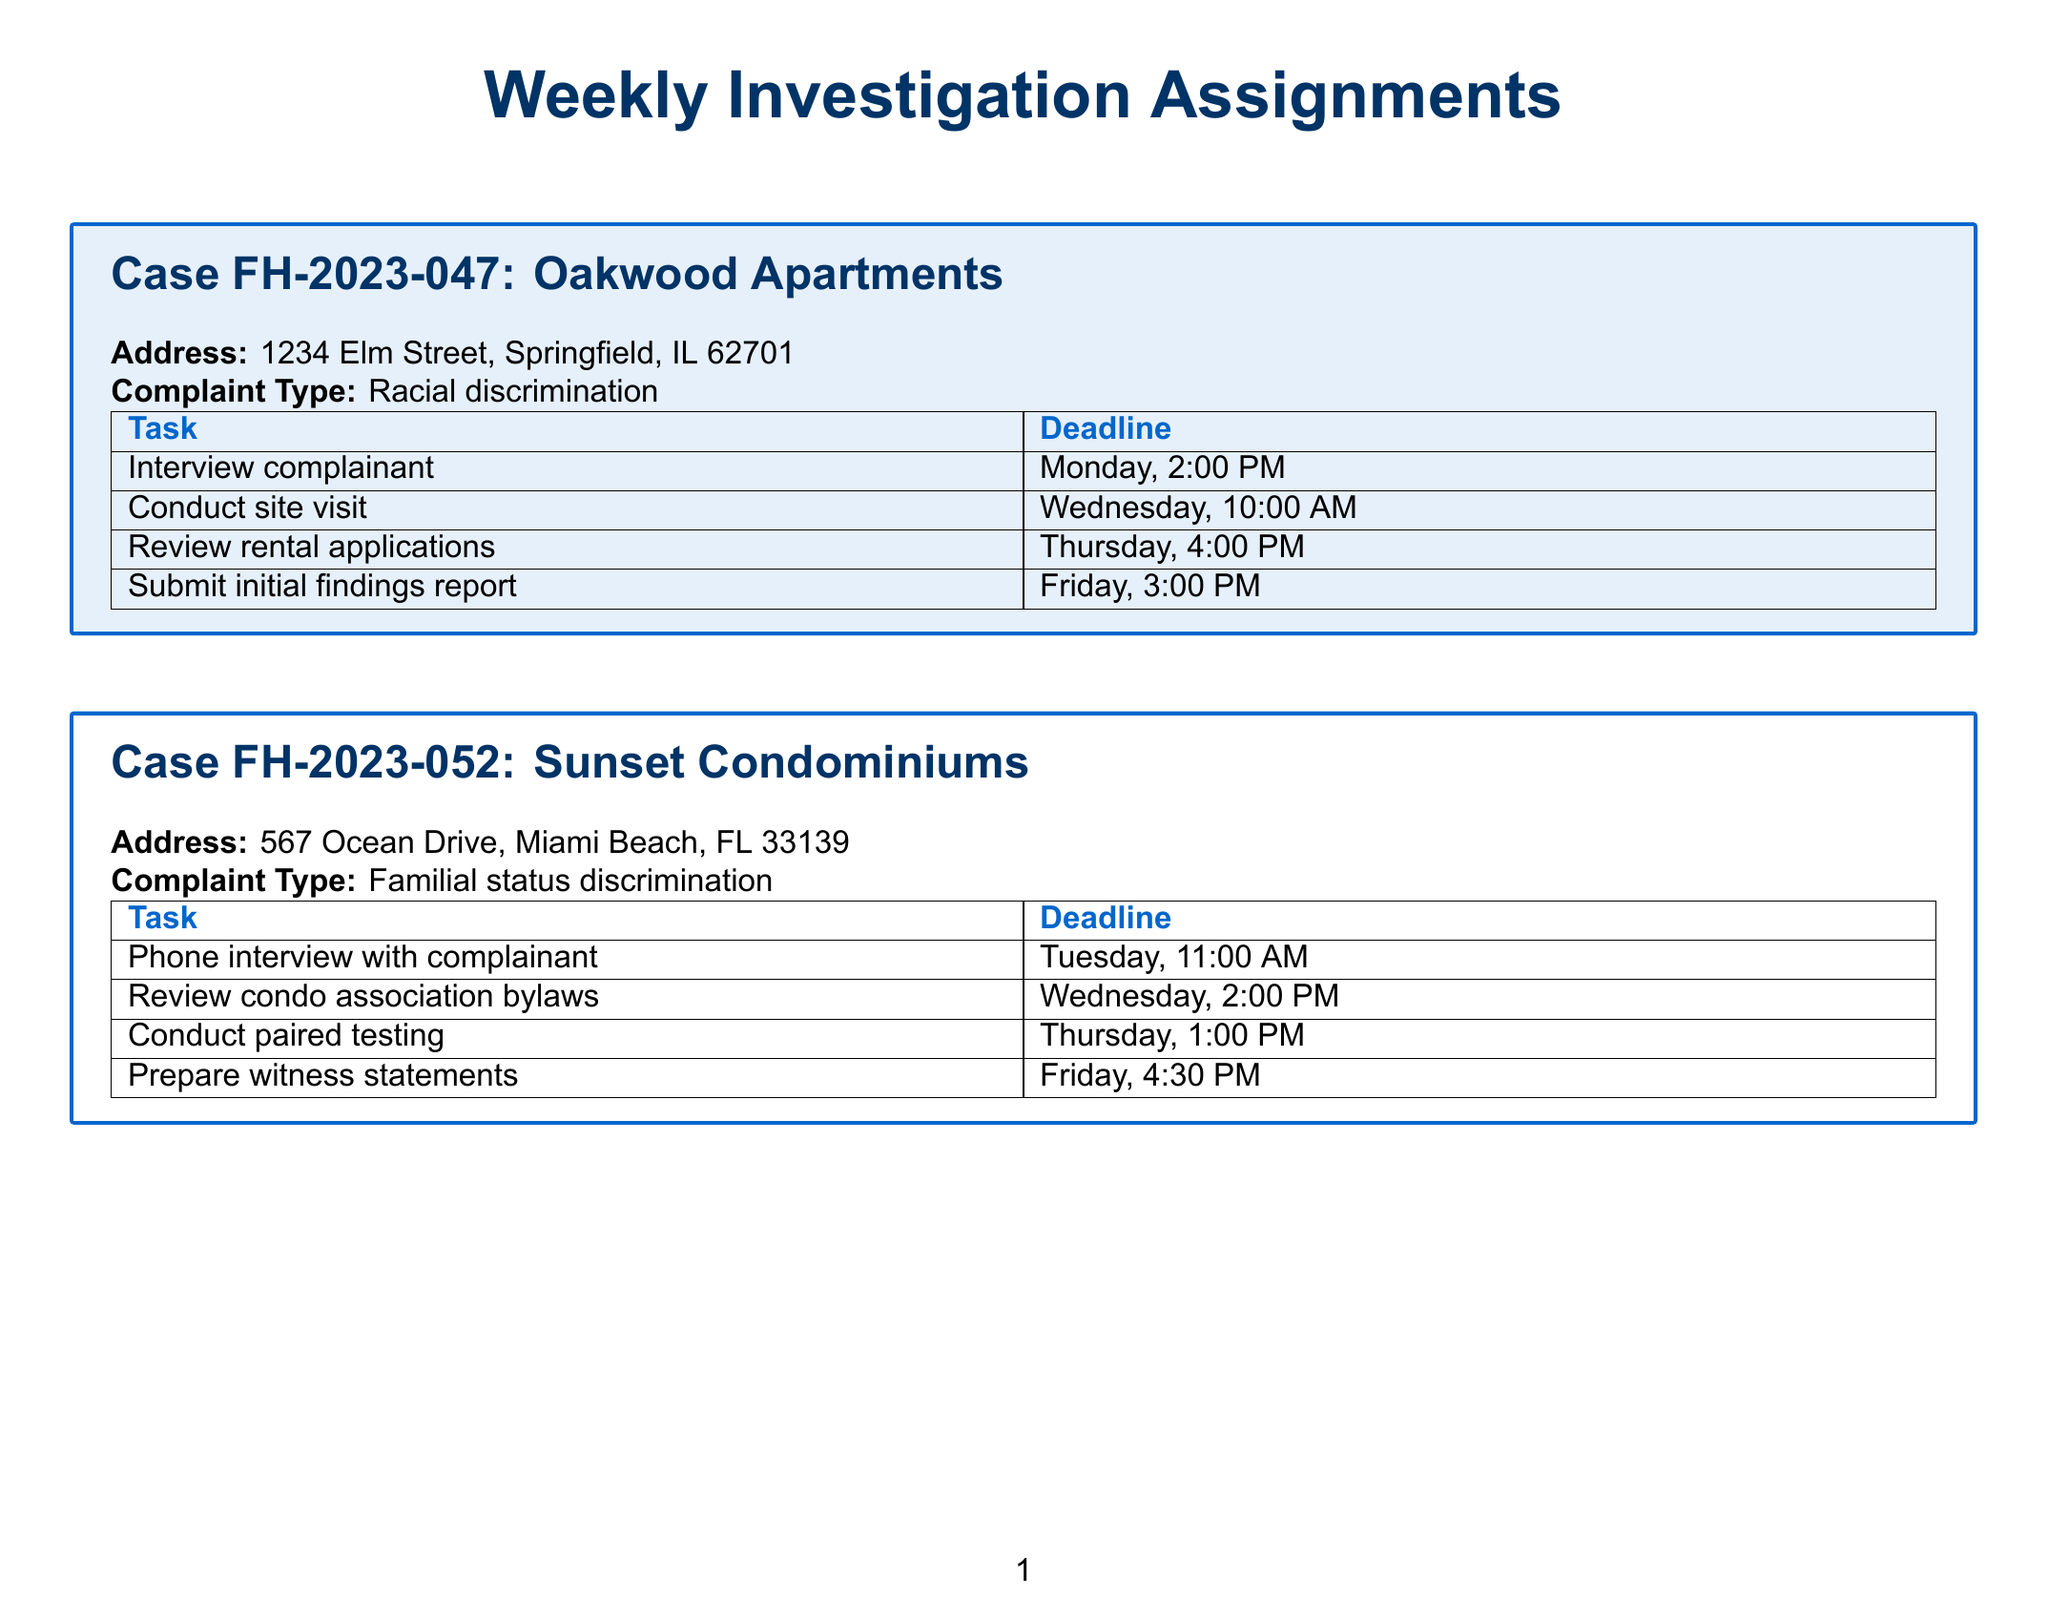What is the case number for Oakwood Apartments? The case number for Oakwood Apartments is specifically mentioned as FH-2023-047 in the document.
Answer: FH-2023-047 What is the deadline for the phone interview with the complainant in the Sunset Condominiums case? The document states that the phone interview with the complainant must be completed by Tuesday at 11:00 AM.
Answer: Tuesday, 11:00 AM How many tasks are associated with the Green Meadows Assisted Living case? By counting the tasks listed, we can determine that there are four tasks associated with this particular case.
Answer: 4 What is the complaint type for Riverfront Townhomes? The complaint type is listed as Source of income discrimination in the section about Riverfront Townhomes.
Answer: Source of income discrimination When is the deadline for submitting the initial findings report for Oakwood Apartments? The document specifies that the initial findings report is due on Friday at 3:00 PM.
Answer: Friday, 3:00 PM What task is scheduled for Thursday, 2:00 PM in Green Meadows Assisted Living? The scheduled task at this time is to consult with the ADA specialist as indicated in the document.
Answer: Consult with ADA specialist Which property has a complaint type related to familial status? The property mentioned with a complaint type related to familial status is Sunset Condominiums as per the document.
Answer: Sunset Condominiums What is the deadline for compiling demographic data in Mountain View Estates? According to the document, the deadline for this task is Friday at 3:30 PM.
Answer: Friday, 3:30 PM Which task is due on Monday for the Riverfront Townhomes case? The document indicates that reviewing rental criteria is the task due on Monday for this case.
Answer: Review rental criteria 